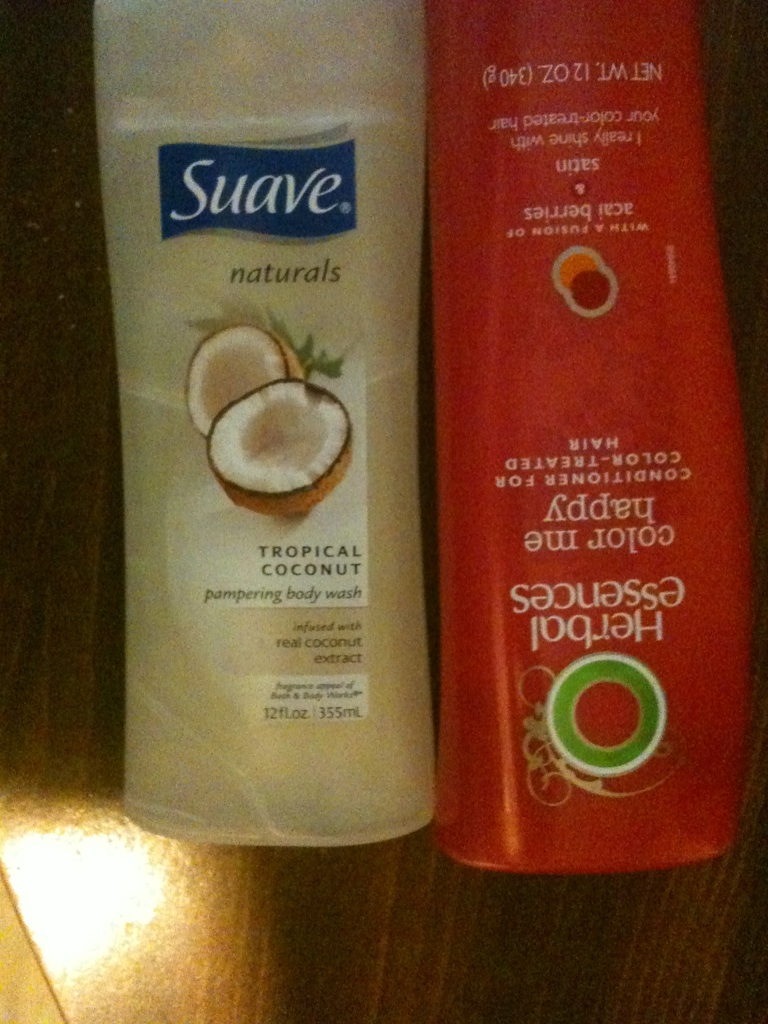If these products could talk, what kind of conversation do you think they would have? Suave Body Wash: 'Ah, there's nothing like a refreshing coconut scent to start the day! I make people feel like they're on a tropical vacation every time they shower.'
Herbal Essences Conditioner: 'True, but don't forget the importance of maintaining vibrant, color-treated hair. I ensure hair stays beautiful and radiant, making people feel glamorous every single day.'
Suave Body Wash: 'Together, we make a great team – pampering skin and revamping hair to create a luxurious spa experience at home!' 